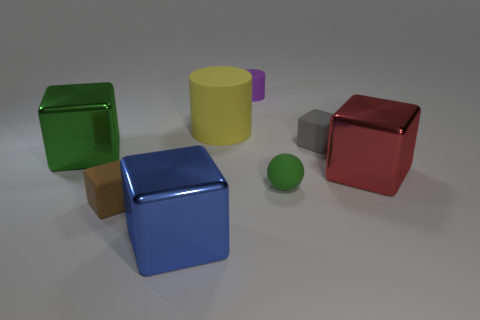Subtract all brown rubber cubes. How many cubes are left? 4 Add 1 tiny brown things. How many objects exist? 9 Subtract all brown cubes. How many cubes are left? 4 Subtract all brown cubes. Subtract all gray balls. How many cubes are left? 4 Subtract all cylinders. How many objects are left? 6 Add 1 small brown rubber blocks. How many small brown rubber blocks are left? 2 Add 6 tiny red cubes. How many tiny red cubes exist? 6 Subtract 1 green balls. How many objects are left? 7 Subtract all large blue metallic objects. Subtract all tiny cylinders. How many objects are left? 6 